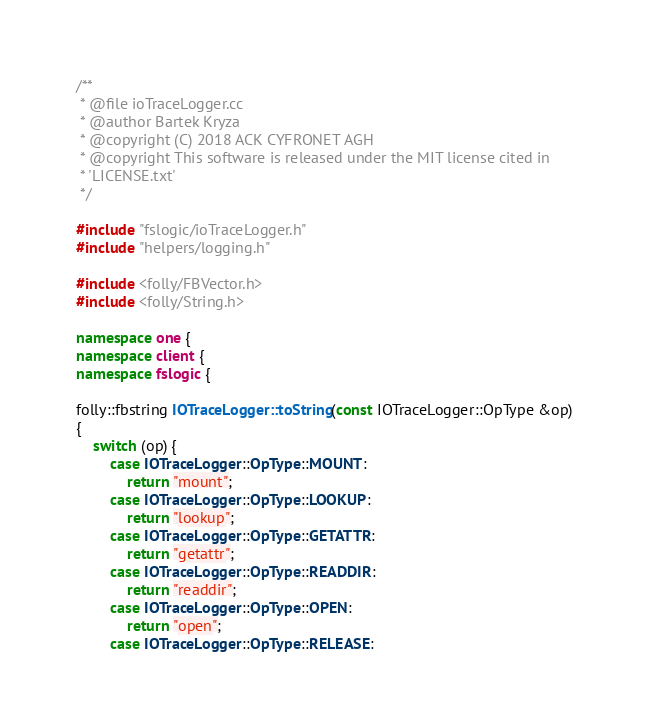<code> <loc_0><loc_0><loc_500><loc_500><_C++_>/**
 * @file ioTraceLogger.cc
 * @author Bartek Kryza
 * @copyright (C) 2018 ACK CYFRONET AGH
 * @copyright This software is released under the MIT license cited in
 * 'LICENSE.txt'
 */

#include "fslogic/ioTraceLogger.h"
#include "helpers/logging.h"

#include <folly/FBVector.h>
#include <folly/String.h>

namespace one {
namespace client {
namespace fslogic {

folly::fbstring IOTraceLogger::toString(const IOTraceLogger::OpType &op)
{
    switch (op) {
        case IOTraceLogger::OpType::MOUNT:
            return "mount";
        case IOTraceLogger::OpType::LOOKUP:
            return "lookup";
        case IOTraceLogger::OpType::GETATTR:
            return "getattr";
        case IOTraceLogger::OpType::READDIR:
            return "readdir";
        case IOTraceLogger::OpType::OPEN:
            return "open";
        case IOTraceLogger::OpType::RELEASE:</code> 